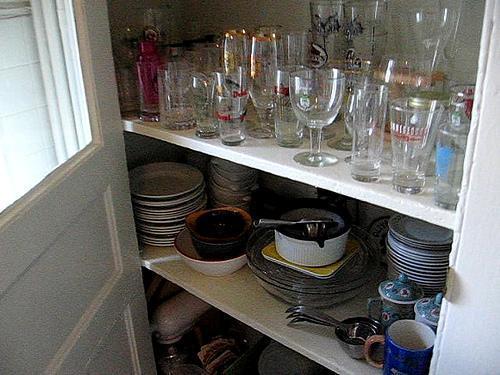How many bowls can you see?
Give a very brief answer. 2. How many cups are visible?
Give a very brief answer. 6. How many wine glasses can you see?
Give a very brief answer. 3. 